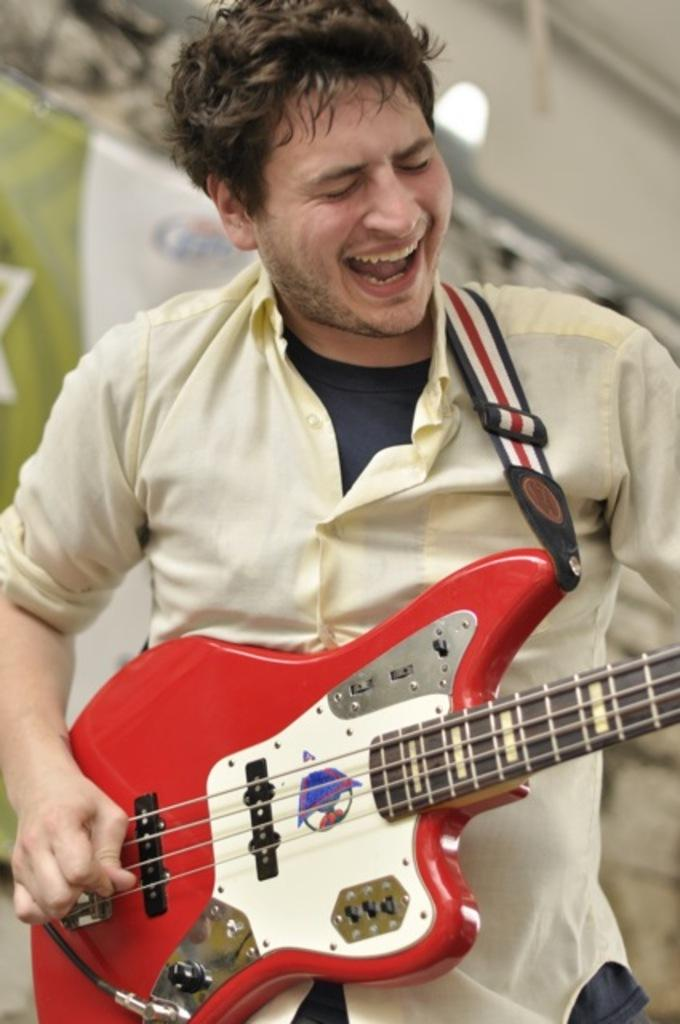What is the main subject of the image? The main subject of the image is a man. What is the man doing in the image? The man is playing a guitar in the image. What color is the man's underwear in the image? There is no information about the man's underwear in the image, and therefore it cannot be determined. 